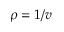Convert formula to latex. <formula><loc_0><loc_0><loc_500><loc_500>\rho = 1 / v</formula> 